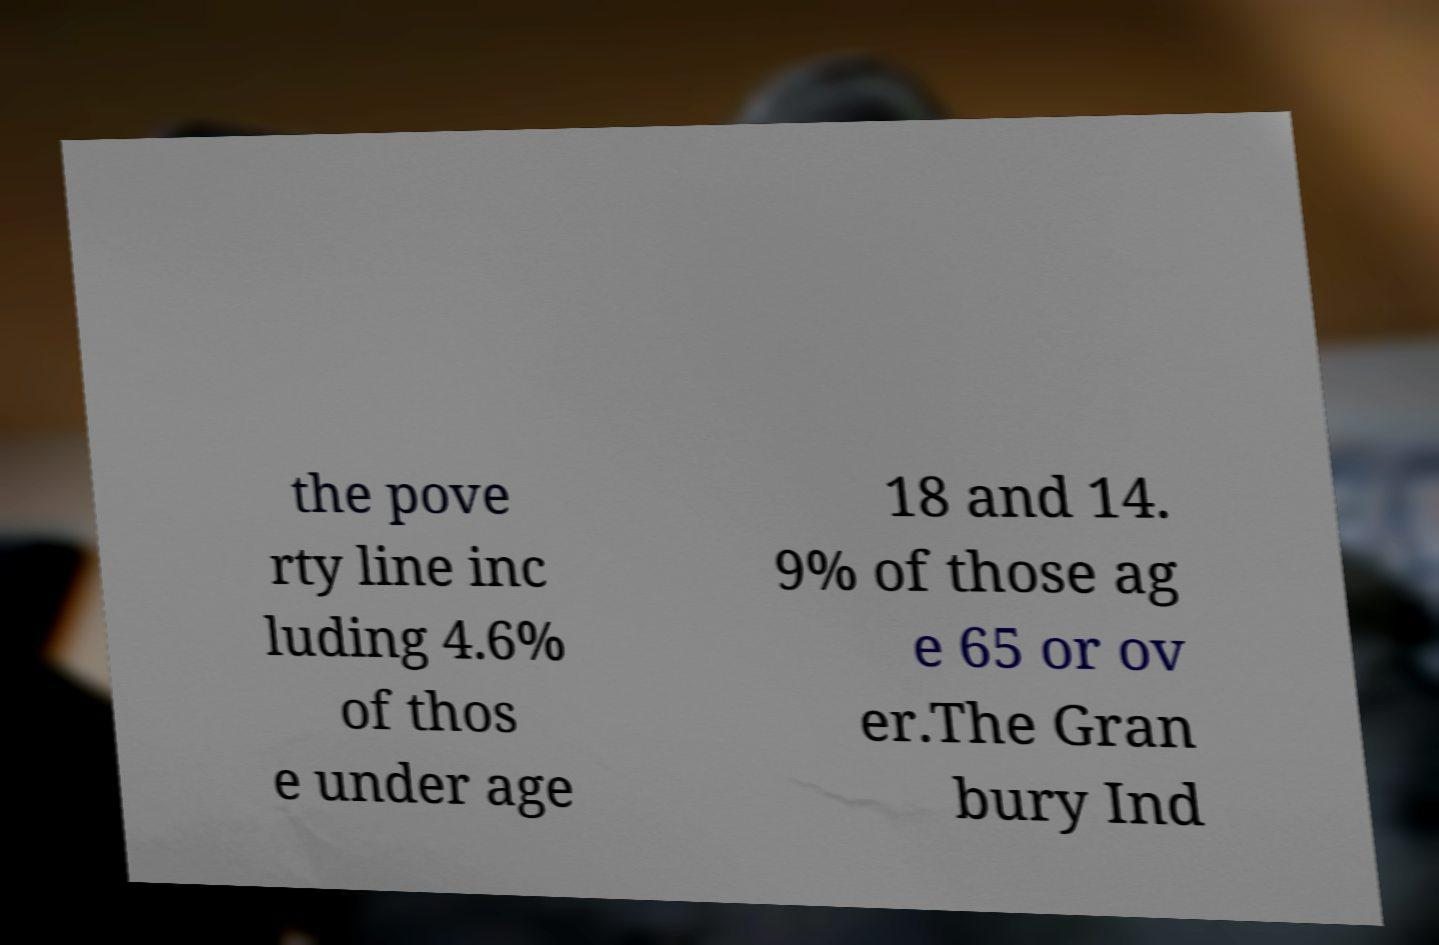What messages or text are displayed in this image? I need them in a readable, typed format. the pove rty line inc luding 4.6% of thos e under age 18 and 14. 9% of those ag e 65 or ov er.The Gran bury Ind 